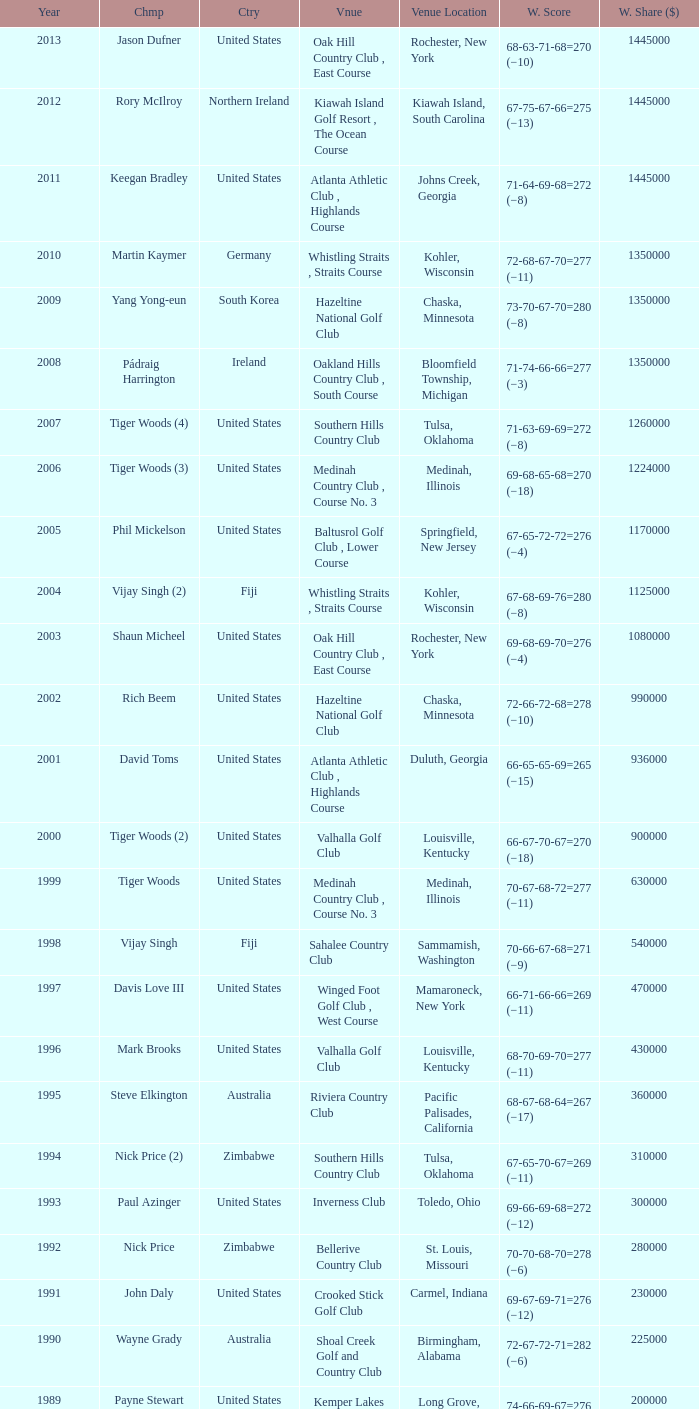Where can one find the bellerive country club venue situated? St. Louis, Missouri. 